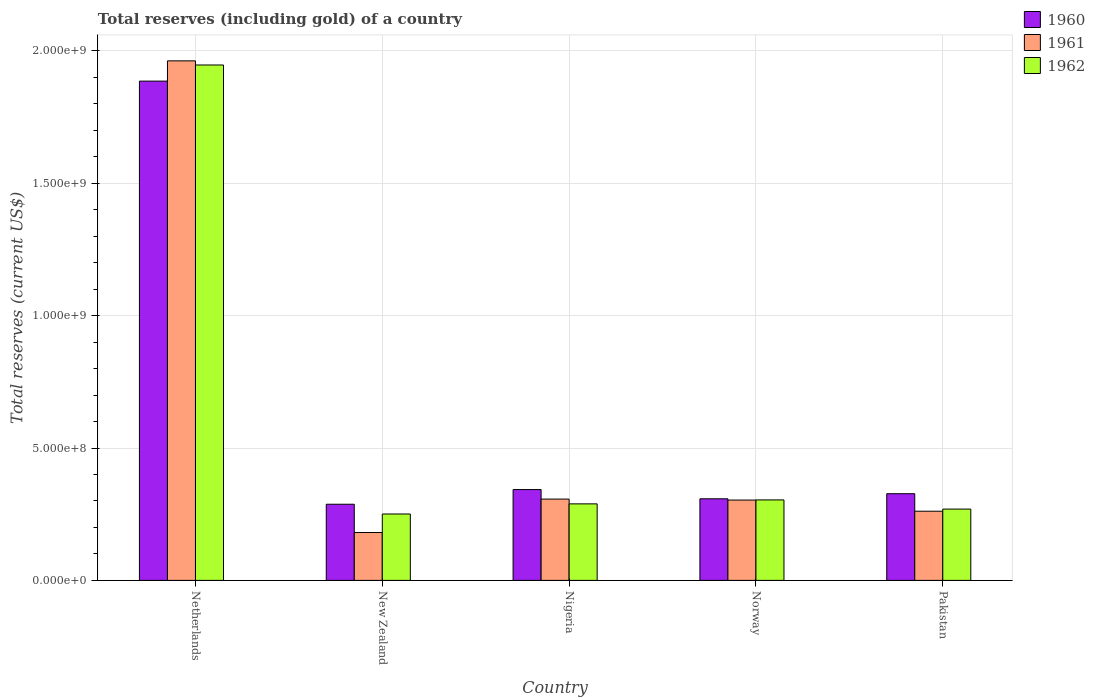How many different coloured bars are there?
Ensure brevity in your answer.  3. Are the number of bars on each tick of the X-axis equal?
Your answer should be very brief. Yes. What is the label of the 3rd group of bars from the left?
Give a very brief answer. Nigeria. In how many cases, is the number of bars for a given country not equal to the number of legend labels?
Your response must be concise. 0. What is the total reserves (including gold) in 1962 in Norway?
Provide a short and direct response. 3.04e+08. Across all countries, what is the maximum total reserves (including gold) in 1960?
Your answer should be very brief. 1.89e+09. Across all countries, what is the minimum total reserves (including gold) in 1961?
Keep it short and to the point. 1.81e+08. In which country was the total reserves (including gold) in 1961 maximum?
Keep it short and to the point. Netherlands. In which country was the total reserves (including gold) in 1961 minimum?
Provide a succinct answer. New Zealand. What is the total total reserves (including gold) in 1960 in the graph?
Your answer should be compact. 3.15e+09. What is the difference between the total reserves (including gold) in 1962 in New Zealand and that in Nigeria?
Keep it short and to the point. -3.82e+07. What is the difference between the total reserves (including gold) in 1961 in Norway and the total reserves (including gold) in 1962 in Nigeria?
Provide a succinct answer. 1.44e+07. What is the average total reserves (including gold) in 1962 per country?
Offer a very short reply. 6.12e+08. What is the difference between the total reserves (including gold) of/in 1962 and total reserves (including gold) of/in 1961 in Norway?
Offer a terse response. 5.46e+05. What is the ratio of the total reserves (including gold) in 1960 in Netherlands to that in Nigeria?
Provide a short and direct response. 5.5. What is the difference between the highest and the second highest total reserves (including gold) in 1960?
Offer a very short reply. 1.56e+07. What is the difference between the highest and the lowest total reserves (including gold) in 1962?
Offer a terse response. 1.70e+09. Is the sum of the total reserves (including gold) in 1962 in Netherlands and Norway greater than the maximum total reserves (including gold) in 1960 across all countries?
Make the answer very short. Yes. What does the 1st bar from the left in Netherlands represents?
Provide a short and direct response. 1960. How many bars are there?
Ensure brevity in your answer.  15. How many countries are there in the graph?
Your answer should be compact. 5. What is the difference between two consecutive major ticks on the Y-axis?
Ensure brevity in your answer.  5.00e+08. Are the values on the major ticks of Y-axis written in scientific E-notation?
Ensure brevity in your answer.  Yes. Does the graph contain grids?
Keep it short and to the point. Yes. How many legend labels are there?
Give a very brief answer. 3. How are the legend labels stacked?
Ensure brevity in your answer.  Vertical. What is the title of the graph?
Provide a succinct answer. Total reserves (including gold) of a country. Does "1984" appear as one of the legend labels in the graph?
Provide a short and direct response. No. What is the label or title of the X-axis?
Give a very brief answer. Country. What is the label or title of the Y-axis?
Your answer should be very brief. Total reserves (current US$). What is the Total reserves (current US$) in 1960 in Netherlands?
Make the answer very short. 1.89e+09. What is the Total reserves (current US$) in 1961 in Netherlands?
Give a very brief answer. 1.96e+09. What is the Total reserves (current US$) of 1962 in Netherlands?
Provide a succinct answer. 1.95e+09. What is the Total reserves (current US$) in 1960 in New Zealand?
Offer a terse response. 2.88e+08. What is the Total reserves (current US$) in 1961 in New Zealand?
Ensure brevity in your answer.  1.81e+08. What is the Total reserves (current US$) in 1962 in New Zealand?
Your response must be concise. 2.51e+08. What is the Total reserves (current US$) in 1960 in Nigeria?
Your response must be concise. 3.43e+08. What is the Total reserves (current US$) of 1961 in Nigeria?
Offer a very short reply. 3.07e+08. What is the Total reserves (current US$) of 1962 in Nigeria?
Provide a succinct answer. 2.89e+08. What is the Total reserves (current US$) in 1960 in Norway?
Your answer should be compact. 3.08e+08. What is the Total reserves (current US$) in 1961 in Norway?
Give a very brief answer. 3.03e+08. What is the Total reserves (current US$) in 1962 in Norway?
Your answer should be compact. 3.04e+08. What is the Total reserves (current US$) in 1960 in Pakistan?
Provide a succinct answer. 3.27e+08. What is the Total reserves (current US$) in 1961 in Pakistan?
Make the answer very short. 2.61e+08. What is the Total reserves (current US$) in 1962 in Pakistan?
Offer a terse response. 2.69e+08. Across all countries, what is the maximum Total reserves (current US$) in 1960?
Keep it short and to the point. 1.89e+09. Across all countries, what is the maximum Total reserves (current US$) of 1961?
Your answer should be very brief. 1.96e+09. Across all countries, what is the maximum Total reserves (current US$) in 1962?
Your response must be concise. 1.95e+09. Across all countries, what is the minimum Total reserves (current US$) of 1960?
Offer a very short reply. 2.88e+08. Across all countries, what is the minimum Total reserves (current US$) in 1961?
Your answer should be compact. 1.81e+08. Across all countries, what is the minimum Total reserves (current US$) of 1962?
Your answer should be very brief. 2.51e+08. What is the total Total reserves (current US$) in 1960 in the graph?
Your answer should be very brief. 3.15e+09. What is the total Total reserves (current US$) in 1961 in the graph?
Offer a terse response. 3.01e+09. What is the total Total reserves (current US$) of 1962 in the graph?
Your response must be concise. 3.06e+09. What is the difference between the Total reserves (current US$) in 1960 in Netherlands and that in New Zealand?
Your answer should be very brief. 1.60e+09. What is the difference between the Total reserves (current US$) in 1961 in Netherlands and that in New Zealand?
Provide a short and direct response. 1.78e+09. What is the difference between the Total reserves (current US$) of 1962 in Netherlands and that in New Zealand?
Provide a succinct answer. 1.70e+09. What is the difference between the Total reserves (current US$) of 1960 in Netherlands and that in Nigeria?
Ensure brevity in your answer.  1.54e+09. What is the difference between the Total reserves (current US$) in 1961 in Netherlands and that in Nigeria?
Your answer should be compact. 1.66e+09. What is the difference between the Total reserves (current US$) of 1962 in Netherlands and that in Nigeria?
Give a very brief answer. 1.66e+09. What is the difference between the Total reserves (current US$) in 1960 in Netherlands and that in Norway?
Offer a very short reply. 1.58e+09. What is the difference between the Total reserves (current US$) in 1961 in Netherlands and that in Norway?
Offer a terse response. 1.66e+09. What is the difference between the Total reserves (current US$) of 1962 in Netherlands and that in Norway?
Ensure brevity in your answer.  1.64e+09. What is the difference between the Total reserves (current US$) of 1960 in Netherlands and that in Pakistan?
Ensure brevity in your answer.  1.56e+09. What is the difference between the Total reserves (current US$) in 1961 in Netherlands and that in Pakistan?
Your answer should be compact. 1.70e+09. What is the difference between the Total reserves (current US$) in 1962 in Netherlands and that in Pakistan?
Make the answer very short. 1.68e+09. What is the difference between the Total reserves (current US$) in 1960 in New Zealand and that in Nigeria?
Offer a very short reply. -5.54e+07. What is the difference between the Total reserves (current US$) of 1961 in New Zealand and that in Nigeria?
Your answer should be very brief. -1.26e+08. What is the difference between the Total reserves (current US$) in 1962 in New Zealand and that in Nigeria?
Give a very brief answer. -3.82e+07. What is the difference between the Total reserves (current US$) of 1960 in New Zealand and that in Norway?
Ensure brevity in your answer.  -2.06e+07. What is the difference between the Total reserves (current US$) of 1961 in New Zealand and that in Norway?
Provide a succinct answer. -1.23e+08. What is the difference between the Total reserves (current US$) of 1962 in New Zealand and that in Norway?
Your response must be concise. -5.32e+07. What is the difference between the Total reserves (current US$) in 1960 in New Zealand and that in Pakistan?
Your answer should be very brief. -3.98e+07. What is the difference between the Total reserves (current US$) of 1961 in New Zealand and that in Pakistan?
Your answer should be very brief. -8.05e+07. What is the difference between the Total reserves (current US$) of 1962 in New Zealand and that in Pakistan?
Make the answer very short. -1.85e+07. What is the difference between the Total reserves (current US$) of 1960 in Nigeria and that in Norway?
Offer a terse response. 3.48e+07. What is the difference between the Total reserves (current US$) of 1961 in Nigeria and that in Norway?
Offer a terse response. 3.64e+06. What is the difference between the Total reserves (current US$) of 1962 in Nigeria and that in Norway?
Provide a succinct answer. -1.50e+07. What is the difference between the Total reserves (current US$) of 1960 in Nigeria and that in Pakistan?
Your answer should be compact. 1.56e+07. What is the difference between the Total reserves (current US$) of 1961 in Nigeria and that in Pakistan?
Your answer should be compact. 4.58e+07. What is the difference between the Total reserves (current US$) in 1962 in Nigeria and that in Pakistan?
Keep it short and to the point. 1.97e+07. What is the difference between the Total reserves (current US$) of 1960 in Norway and that in Pakistan?
Your answer should be compact. -1.92e+07. What is the difference between the Total reserves (current US$) in 1961 in Norway and that in Pakistan?
Provide a short and direct response. 4.21e+07. What is the difference between the Total reserves (current US$) in 1962 in Norway and that in Pakistan?
Your response must be concise. 3.47e+07. What is the difference between the Total reserves (current US$) of 1960 in Netherlands and the Total reserves (current US$) of 1961 in New Zealand?
Give a very brief answer. 1.70e+09. What is the difference between the Total reserves (current US$) of 1960 in Netherlands and the Total reserves (current US$) of 1962 in New Zealand?
Give a very brief answer. 1.63e+09. What is the difference between the Total reserves (current US$) of 1961 in Netherlands and the Total reserves (current US$) of 1962 in New Zealand?
Make the answer very short. 1.71e+09. What is the difference between the Total reserves (current US$) of 1960 in Netherlands and the Total reserves (current US$) of 1961 in Nigeria?
Make the answer very short. 1.58e+09. What is the difference between the Total reserves (current US$) in 1960 in Netherlands and the Total reserves (current US$) in 1962 in Nigeria?
Your response must be concise. 1.60e+09. What is the difference between the Total reserves (current US$) of 1961 in Netherlands and the Total reserves (current US$) of 1962 in Nigeria?
Provide a short and direct response. 1.67e+09. What is the difference between the Total reserves (current US$) of 1960 in Netherlands and the Total reserves (current US$) of 1961 in Norway?
Provide a succinct answer. 1.58e+09. What is the difference between the Total reserves (current US$) in 1960 in Netherlands and the Total reserves (current US$) in 1962 in Norway?
Offer a terse response. 1.58e+09. What is the difference between the Total reserves (current US$) of 1961 in Netherlands and the Total reserves (current US$) of 1962 in Norway?
Ensure brevity in your answer.  1.66e+09. What is the difference between the Total reserves (current US$) of 1960 in Netherlands and the Total reserves (current US$) of 1961 in Pakistan?
Give a very brief answer. 1.62e+09. What is the difference between the Total reserves (current US$) in 1960 in Netherlands and the Total reserves (current US$) in 1962 in Pakistan?
Your answer should be compact. 1.62e+09. What is the difference between the Total reserves (current US$) in 1961 in Netherlands and the Total reserves (current US$) in 1962 in Pakistan?
Offer a terse response. 1.69e+09. What is the difference between the Total reserves (current US$) in 1960 in New Zealand and the Total reserves (current US$) in 1961 in Nigeria?
Give a very brief answer. -1.95e+07. What is the difference between the Total reserves (current US$) in 1960 in New Zealand and the Total reserves (current US$) in 1962 in Nigeria?
Ensure brevity in your answer.  -1.43e+06. What is the difference between the Total reserves (current US$) of 1961 in New Zealand and the Total reserves (current US$) of 1962 in Nigeria?
Offer a terse response. -1.08e+08. What is the difference between the Total reserves (current US$) of 1960 in New Zealand and the Total reserves (current US$) of 1961 in Norway?
Make the answer very short. -1.58e+07. What is the difference between the Total reserves (current US$) of 1960 in New Zealand and the Total reserves (current US$) of 1962 in Norway?
Offer a terse response. -1.64e+07. What is the difference between the Total reserves (current US$) in 1961 in New Zealand and the Total reserves (current US$) in 1962 in Norway?
Provide a succinct answer. -1.23e+08. What is the difference between the Total reserves (current US$) in 1960 in New Zealand and the Total reserves (current US$) in 1961 in Pakistan?
Provide a succinct answer. 2.63e+07. What is the difference between the Total reserves (current US$) of 1960 in New Zealand and the Total reserves (current US$) of 1962 in Pakistan?
Offer a terse response. 1.83e+07. What is the difference between the Total reserves (current US$) of 1961 in New Zealand and the Total reserves (current US$) of 1962 in Pakistan?
Your answer should be compact. -8.85e+07. What is the difference between the Total reserves (current US$) in 1960 in Nigeria and the Total reserves (current US$) in 1961 in Norway?
Ensure brevity in your answer.  3.96e+07. What is the difference between the Total reserves (current US$) in 1960 in Nigeria and the Total reserves (current US$) in 1962 in Norway?
Your response must be concise. 3.90e+07. What is the difference between the Total reserves (current US$) of 1961 in Nigeria and the Total reserves (current US$) of 1962 in Norway?
Provide a short and direct response. 3.09e+06. What is the difference between the Total reserves (current US$) of 1960 in Nigeria and the Total reserves (current US$) of 1961 in Pakistan?
Ensure brevity in your answer.  8.17e+07. What is the difference between the Total reserves (current US$) of 1960 in Nigeria and the Total reserves (current US$) of 1962 in Pakistan?
Give a very brief answer. 7.37e+07. What is the difference between the Total reserves (current US$) of 1961 in Nigeria and the Total reserves (current US$) of 1962 in Pakistan?
Your answer should be compact. 3.78e+07. What is the difference between the Total reserves (current US$) of 1960 in Norway and the Total reserves (current US$) of 1961 in Pakistan?
Offer a terse response. 4.69e+07. What is the difference between the Total reserves (current US$) in 1960 in Norway and the Total reserves (current US$) in 1962 in Pakistan?
Offer a very short reply. 3.89e+07. What is the difference between the Total reserves (current US$) in 1961 in Norway and the Total reserves (current US$) in 1962 in Pakistan?
Give a very brief answer. 3.41e+07. What is the average Total reserves (current US$) in 1960 per country?
Make the answer very short. 6.30e+08. What is the average Total reserves (current US$) in 1961 per country?
Make the answer very short. 6.03e+08. What is the average Total reserves (current US$) in 1962 per country?
Your response must be concise. 6.12e+08. What is the difference between the Total reserves (current US$) in 1960 and Total reserves (current US$) in 1961 in Netherlands?
Provide a succinct answer. -7.65e+07. What is the difference between the Total reserves (current US$) in 1960 and Total reserves (current US$) in 1962 in Netherlands?
Make the answer very short. -6.09e+07. What is the difference between the Total reserves (current US$) in 1961 and Total reserves (current US$) in 1962 in Netherlands?
Ensure brevity in your answer.  1.56e+07. What is the difference between the Total reserves (current US$) in 1960 and Total reserves (current US$) in 1961 in New Zealand?
Ensure brevity in your answer.  1.07e+08. What is the difference between the Total reserves (current US$) in 1960 and Total reserves (current US$) in 1962 in New Zealand?
Provide a succinct answer. 3.68e+07. What is the difference between the Total reserves (current US$) of 1961 and Total reserves (current US$) of 1962 in New Zealand?
Offer a terse response. -7.00e+07. What is the difference between the Total reserves (current US$) of 1960 and Total reserves (current US$) of 1961 in Nigeria?
Offer a terse response. 3.59e+07. What is the difference between the Total reserves (current US$) of 1960 and Total reserves (current US$) of 1962 in Nigeria?
Keep it short and to the point. 5.40e+07. What is the difference between the Total reserves (current US$) in 1961 and Total reserves (current US$) in 1962 in Nigeria?
Keep it short and to the point. 1.80e+07. What is the difference between the Total reserves (current US$) of 1960 and Total reserves (current US$) of 1961 in Norway?
Give a very brief answer. 4.75e+06. What is the difference between the Total reserves (current US$) of 1960 and Total reserves (current US$) of 1962 in Norway?
Your response must be concise. 4.20e+06. What is the difference between the Total reserves (current US$) of 1961 and Total reserves (current US$) of 1962 in Norway?
Make the answer very short. -5.46e+05. What is the difference between the Total reserves (current US$) in 1960 and Total reserves (current US$) in 1961 in Pakistan?
Provide a succinct answer. 6.61e+07. What is the difference between the Total reserves (current US$) in 1960 and Total reserves (current US$) in 1962 in Pakistan?
Keep it short and to the point. 5.81e+07. What is the difference between the Total reserves (current US$) of 1961 and Total reserves (current US$) of 1962 in Pakistan?
Provide a short and direct response. -8.01e+06. What is the ratio of the Total reserves (current US$) of 1960 in Netherlands to that in New Zealand?
Your answer should be very brief. 6.56. What is the ratio of the Total reserves (current US$) in 1961 in Netherlands to that in New Zealand?
Make the answer very short. 10.85. What is the ratio of the Total reserves (current US$) of 1962 in Netherlands to that in New Zealand?
Provide a succinct answer. 7.76. What is the ratio of the Total reserves (current US$) in 1960 in Netherlands to that in Nigeria?
Provide a short and direct response. 5.5. What is the ratio of the Total reserves (current US$) in 1961 in Netherlands to that in Nigeria?
Ensure brevity in your answer.  6.39. What is the ratio of the Total reserves (current US$) in 1962 in Netherlands to that in Nigeria?
Keep it short and to the point. 6.74. What is the ratio of the Total reserves (current US$) of 1960 in Netherlands to that in Norway?
Give a very brief answer. 6.12. What is the ratio of the Total reserves (current US$) of 1961 in Netherlands to that in Norway?
Offer a terse response. 6.47. What is the ratio of the Total reserves (current US$) in 1962 in Netherlands to that in Norway?
Offer a very short reply. 6.4. What is the ratio of the Total reserves (current US$) of 1960 in Netherlands to that in Pakistan?
Provide a succinct answer. 5.76. What is the ratio of the Total reserves (current US$) of 1961 in Netherlands to that in Pakistan?
Offer a very short reply. 7.51. What is the ratio of the Total reserves (current US$) of 1962 in Netherlands to that in Pakistan?
Ensure brevity in your answer.  7.23. What is the ratio of the Total reserves (current US$) of 1960 in New Zealand to that in Nigeria?
Offer a very short reply. 0.84. What is the ratio of the Total reserves (current US$) in 1961 in New Zealand to that in Nigeria?
Your answer should be very brief. 0.59. What is the ratio of the Total reserves (current US$) in 1962 in New Zealand to that in Nigeria?
Offer a very short reply. 0.87. What is the ratio of the Total reserves (current US$) of 1960 in New Zealand to that in Norway?
Offer a terse response. 0.93. What is the ratio of the Total reserves (current US$) of 1961 in New Zealand to that in Norway?
Offer a very short reply. 0.6. What is the ratio of the Total reserves (current US$) in 1962 in New Zealand to that in Norway?
Ensure brevity in your answer.  0.83. What is the ratio of the Total reserves (current US$) in 1960 in New Zealand to that in Pakistan?
Keep it short and to the point. 0.88. What is the ratio of the Total reserves (current US$) of 1961 in New Zealand to that in Pakistan?
Your response must be concise. 0.69. What is the ratio of the Total reserves (current US$) in 1962 in New Zealand to that in Pakistan?
Provide a succinct answer. 0.93. What is the ratio of the Total reserves (current US$) in 1960 in Nigeria to that in Norway?
Keep it short and to the point. 1.11. What is the ratio of the Total reserves (current US$) of 1961 in Nigeria to that in Norway?
Ensure brevity in your answer.  1.01. What is the ratio of the Total reserves (current US$) in 1962 in Nigeria to that in Norway?
Ensure brevity in your answer.  0.95. What is the ratio of the Total reserves (current US$) of 1960 in Nigeria to that in Pakistan?
Provide a succinct answer. 1.05. What is the ratio of the Total reserves (current US$) in 1961 in Nigeria to that in Pakistan?
Provide a succinct answer. 1.18. What is the ratio of the Total reserves (current US$) of 1962 in Nigeria to that in Pakistan?
Offer a very short reply. 1.07. What is the ratio of the Total reserves (current US$) of 1960 in Norway to that in Pakistan?
Offer a very short reply. 0.94. What is the ratio of the Total reserves (current US$) of 1961 in Norway to that in Pakistan?
Make the answer very short. 1.16. What is the ratio of the Total reserves (current US$) of 1962 in Norway to that in Pakistan?
Offer a very short reply. 1.13. What is the difference between the highest and the second highest Total reserves (current US$) of 1960?
Provide a short and direct response. 1.54e+09. What is the difference between the highest and the second highest Total reserves (current US$) in 1961?
Your response must be concise. 1.66e+09. What is the difference between the highest and the second highest Total reserves (current US$) of 1962?
Ensure brevity in your answer.  1.64e+09. What is the difference between the highest and the lowest Total reserves (current US$) of 1960?
Ensure brevity in your answer.  1.60e+09. What is the difference between the highest and the lowest Total reserves (current US$) in 1961?
Give a very brief answer. 1.78e+09. What is the difference between the highest and the lowest Total reserves (current US$) of 1962?
Your answer should be compact. 1.70e+09. 